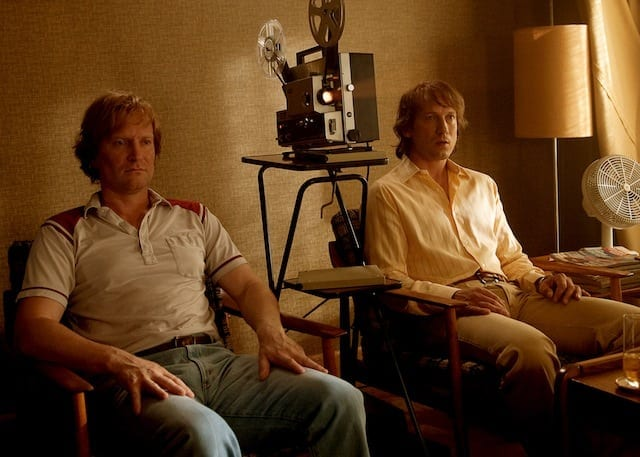Can you create a backstory for the scene depicted in this image? In the summer of 1978, in a small town renowned for its local cinema, two old friends, Jack and Martin, found themselves reminiscing about the past. Jack, dressed in his favorite striped shirt and jeans, often visits Martin, who runs an old film projector business. On this particular evening, as they sat under the warm glow of the lamp, surrounded by the nostalgic remnants of film reels and projections, they talked about their shared passion for movies and their dreams of making a film together one day. The vintage projector in the background symbolizes their long-standing friendship and their undying love for the cinema. 